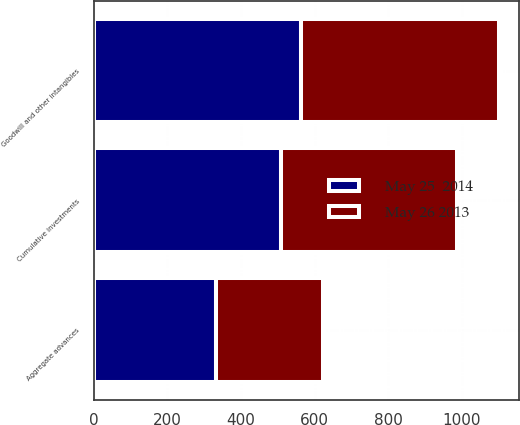Convert chart. <chart><loc_0><loc_0><loc_500><loc_500><stacked_bar_chart><ecel><fcel>Cumulative investments<fcel>Goodwill and other intangibles<fcel>Aggregate advances<nl><fcel>May 25  2014<fcel>507.5<fcel>563.2<fcel>332<nl><fcel>May 26 2013<fcel>478.5<fcel>537.2<fcel>291.5<nl></chart> 